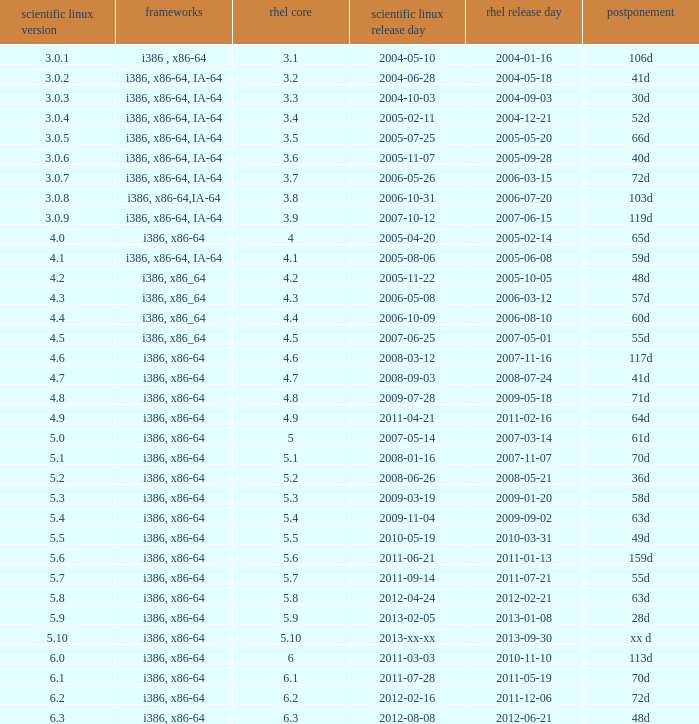Name the delay when scientific linux release is 5.10 Xx d. 